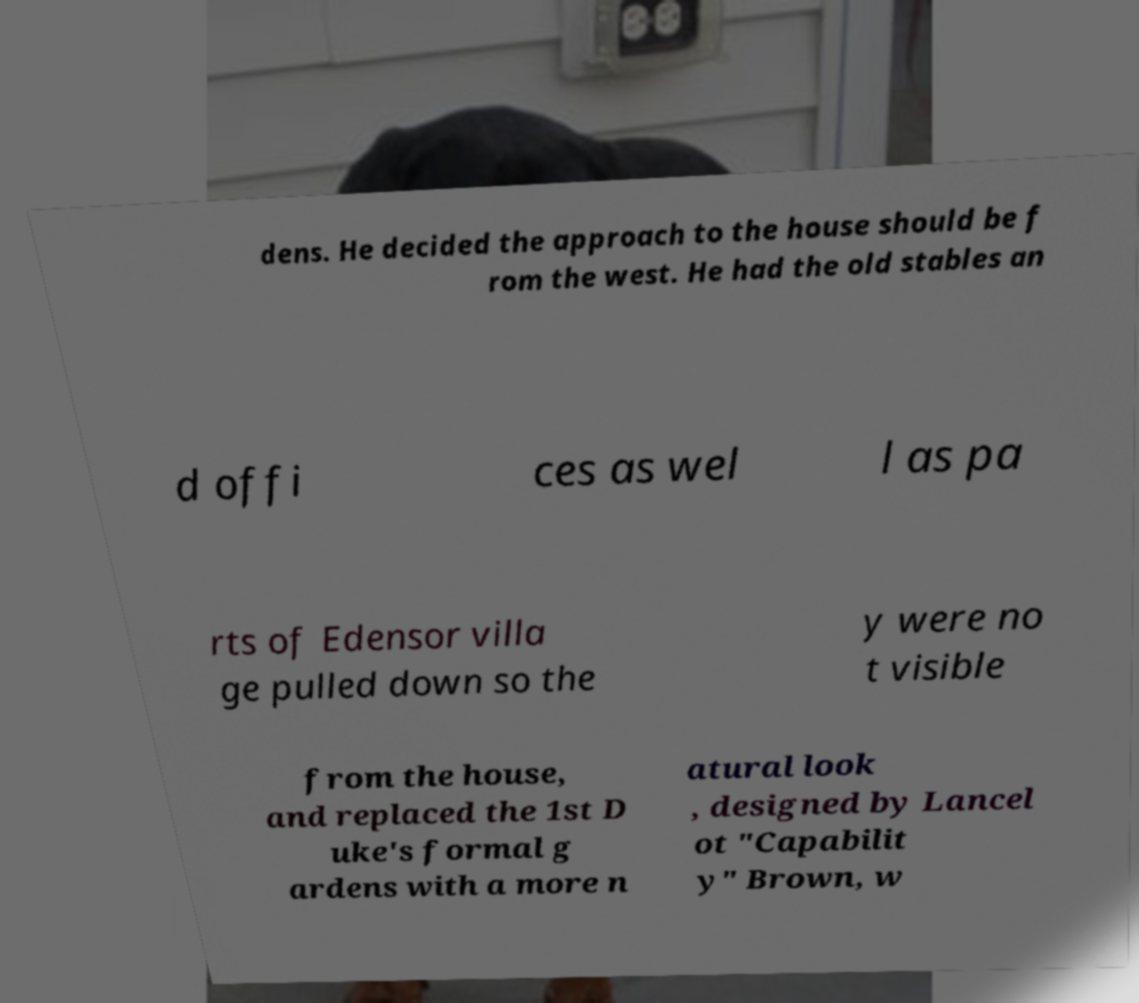For documentation purposes, I need the text within this image transcribed. Could you provide that? dens. He decided the approach to the house should be f rom the west. He had the old stables an d offi ces as wel l as pa rts of Edensor villa ge pulled down so the y were no t visible from the house, and replaced the 1st D uke's formal g ardens with a more n atural look , designed by Lancel ot "Capabilit y" Brown, w 